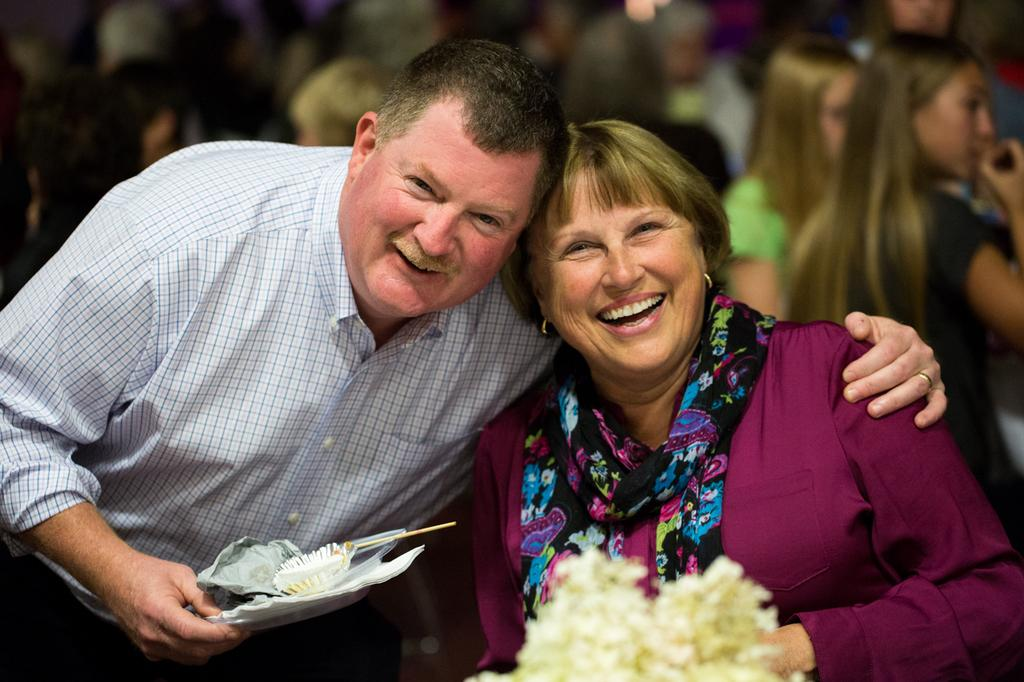Who is present in the image? There is a man and a woman in the image. What is the man holding in the image? The man is holding a plate in the image. What expressions do the man and woman have in the image? Both the man and the woman are smiling in the image. Can you describe the people in the background of the image? There are people in the background of the image, but their specific features are not clear. What type of fruit is the man writing about in the image? There is no fruit or writing present in the image; the man is simply holding a plate. 